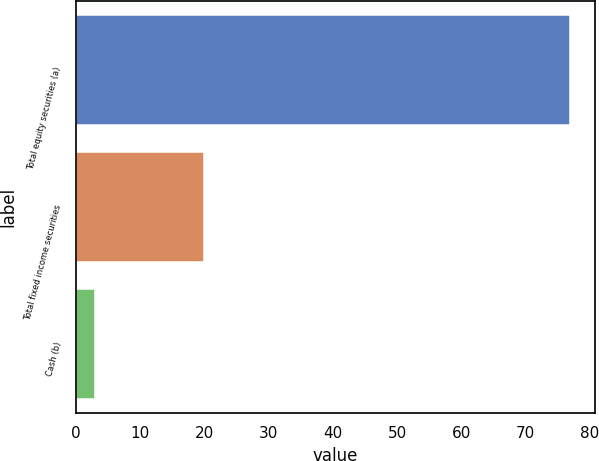Convert chart to OTSL. <chart><loc_0><loc_0><loc_500><loc_500><bar_chart><fcel>Total equity securities (a)<fcel>Total fixed income securities<fcel>Cash (b)<nl><fcel>77<fcel>20<fcel>3<nl></chart> 